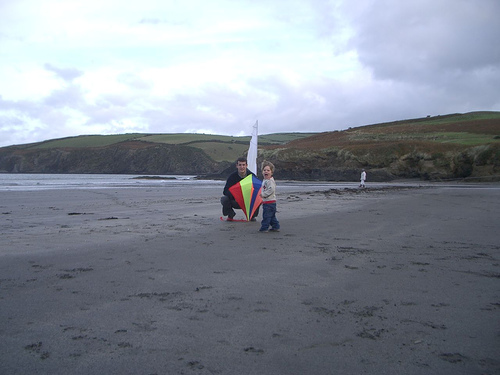<image>Does it look windy enough for this man to fly his kite successfully? I don't know if it looks windy enough for this man to fly his kite successfully. Does it look windy enough for this man to fly his kite successfully? I am not sure if it looks windy enough for this man to fly his kite successfully. It can be both yes or no. 